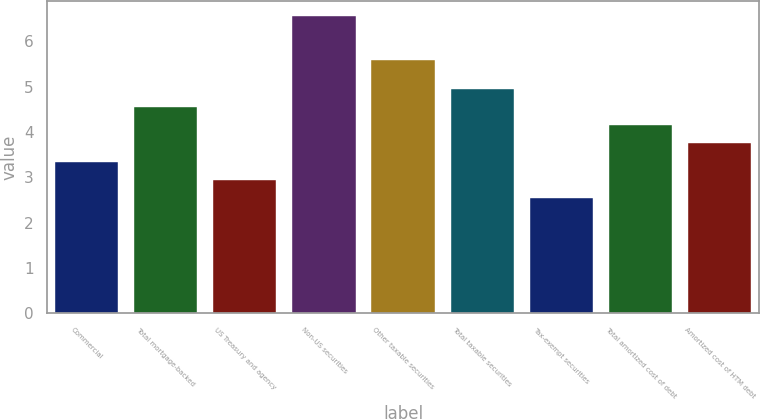<chart> <loc_0><loc_0><loc_500><loc_500><bar_chart><fcel>Commercial<fcel>Total mortgage-backed<fcel>US Treasury and agency<fcel>Non-US securities<fcel>Other taxable securities<fcel>Total taxable securities<fcel>Tax-exempt securities<fcel>Total amortized cost of debt<fcel>Amortized cost of HTM debt<nl><fcel>3.35<fcel>4.55<fcel>2.95<fcel>6.57<fcel>5.59<fcel>4.95<fcel>2.55<fcel>4.15<fcel>3.75<nl></chart> 